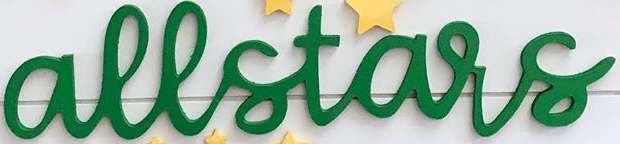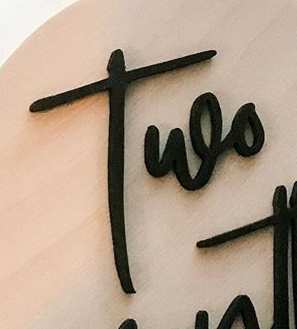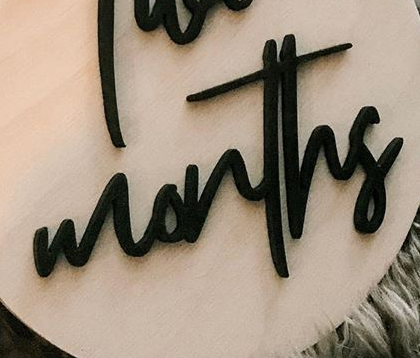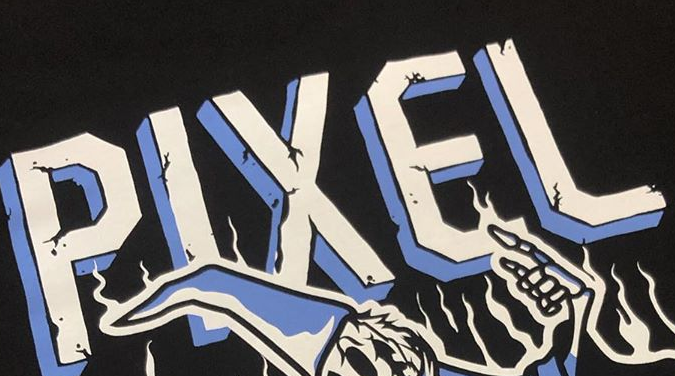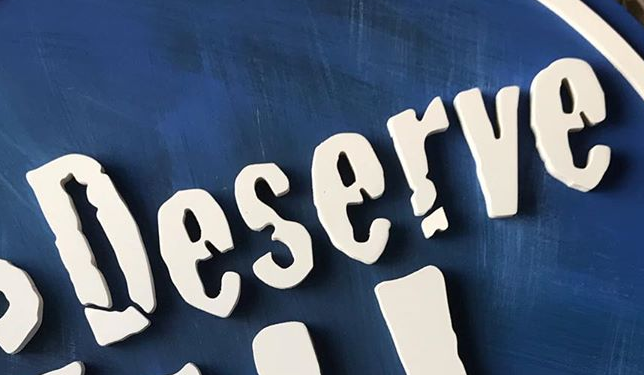What text appears in these images from left to right, separated by a semicolon? allstars; Two; months; PIXEL; Deserve 